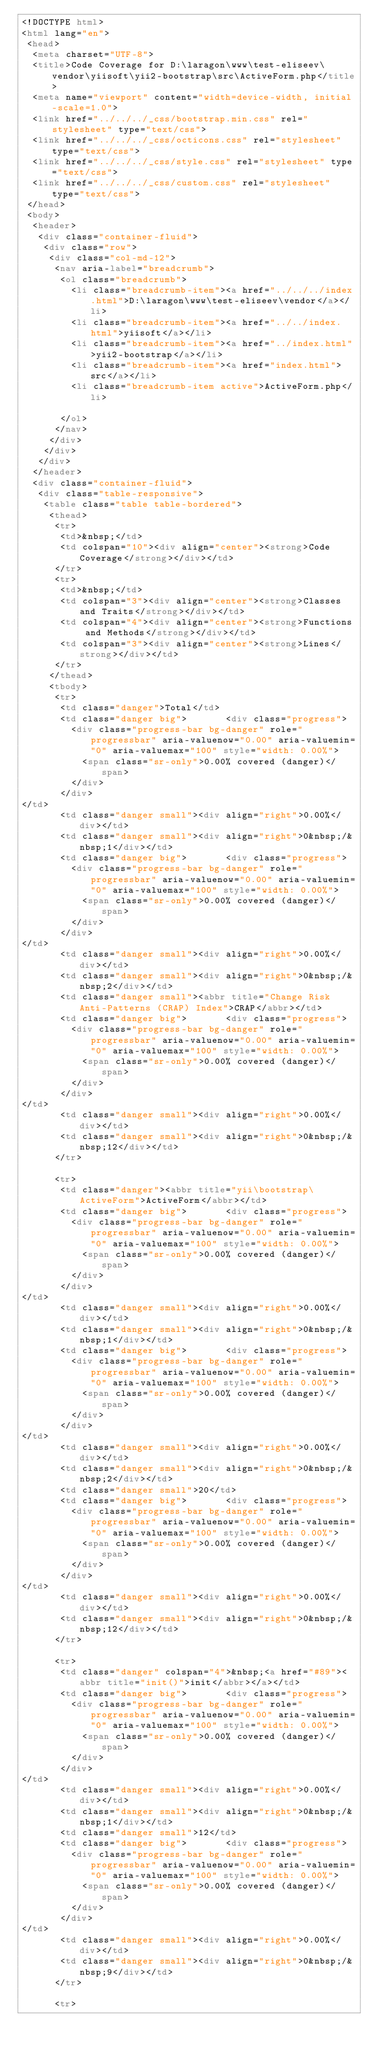Convert code to text. <code><loc_0><loc_0><loc_500><loc_500><_HTML_><!DOCTYPE html>
<html lang="en">
 <head>
  <meta charset="UTF-8">
  <title>Code Coverage for D:\laragon\www\test-eliseev\vendor\yiisoft\yii2-bootstrap\src\ActiveForm.php</title>
  <meta name="viewport" content="width=device-width, initial-scale=1.0">
  <link href="../../../_css/bootstrap.min.css" rel="stylesheet" type="text/css">
  <link href="../../../_css/octicons.css" rel="stylesheet" type="text/css">
  <link href="../../../_css/style.css" rel="stylesheet" type="text/css">
  <link href="../../../_css/custom.css" rel="stylesheet" type="text/css">
 </head>
 <body>
  <header>
   <div class="container-fluid">
    <div class="row">
     <div class="col-md-12">
      <nav aria-label="breadcrumb">
       <ol class="breadcrumb">
         <li class="breadcrumb-item"><a href="../../../index.html">D:\laragon\www\test-eliseev\vendor</a></li>
         <li class="breadcrumb-item"><a href="../../index.html">yiisoft</a></li>
         <li class="breadcrumb-item"><a href="../index.html">yii2-bootstrap</a></li>
         <li class="breadcrumb-item"><a href="index.html">src</a></li>
         <li class="breadcrumb-item active">ActiveForm.php</li>

       </ol>
      </nav>
     </div>
    </div>
   </div>
  </header>
  <div class="container-fluid">
   <div class="table-responsive">
    <table class="table table-bordered">
     <thead>
      <tr>
       <td>&nbsp;</td>
       <td colspan="10"><div align="center"><strong>Code Coverage</strong></div></td>
      </tr>
      <tr>
       <td>&nbsp;</td>
       <td colspan="3"><div align="center"><strong>Classes and Traits</strong></div></td>
       <td colspan="4"><div align="center"><strong>Functions and Methods</strong></div></td>
       <td colspan="3"><div align="center"><strong>Lines</strong></div></td>
      </tr>
     </thead>
     <tbody>
      <tr>
       <td class="danger">Total</td>
       <td class="danger big">       <div class="progress">
         <div class="progress-bar bg-danger" role="progressbar" aria-valuenow="0.00" aria-valuemin="0" aria-valuemax="100" style="width: 0.00%">
           <span class="sr-only">0.00% covered (danger)</span>
         </div>
       </div>
</td>
       <td class="danger small"><div align="right">0.00%</div></td>
       <td class="danger small"><div align="right">0&nbsp;/&nbsp;1</div></td>
       <td class="danger big">       <div class="progress">
         <div class="progress-bar bg-danger" role="progressbar" aria-valuenow="0.00" aria-valuemin="0" aria-valuemax="100" style="width: 0.00%">
           <span class="sr-only">0.00% covered (danger)</span>
         </div>
       </div>
</td>
       <td class="danger small"><div align="right">0.00%</div></td>
       <td class="danger small"><div align="right">0&nbsp;/&nbsp;2</div></td>
       <td class="danger small"><abbr title="Change Risk Anti-Patterns (CRAP) Index">CRAP</abbr></td>
       <td class="danger big">       <div class="progress">
         <div class="progress-bar bg-danger" role="progressbar" aria-valuenow="0.00" aria-valuemin="0" aria-valuemax="100" style="width: 0.00%">
           <span class="sr-only">0.00% covered (danger)</span>
         </div>
       </div>
</td>
       <td class="danger small"><div align="right">0.00%</div></td>
       <td class="danger small"><div align="right">0&nbsp;/&nbsp;12</div></td>
      </tr>

      <tr>
       <td class="danger"><abbr title="yii\bootstrap\ActiveForm">ActiveForm</abbr></td>
       <td class="danger big">       <div class="progress">
         <div class="progress-bar bg-danger" role="progressbar" aria-valuenow="0.00" aria-valuemin="0" aria-valuemax="100" style="width: 0.00%">
           <span class="sr-only">0.00% covered (danger)</span>
         </div>
       </div>
</td>
       <td class="danger small"><div align="right">0.00%</div></td>
       <td class="danger small"><div align="right">0&nbsp;/&nbsp;1</div></td>
       <td class="danger big">       <div class="progress">
         <div class="progress-bar bg-danger" role="progressbar" aria-valuenow="0.00" aria-valuemin="0" aria-valuemax="100" style="width: 0.00%">
           <span class="sr-only">0.00% covered (danger)</span>
         </div>
       </div>
</td>
       <td class="danger small"><div align="right">0.00%</div></td>
       <td class="danger small"><div align="right">0&nbsp;/&nbsp;2</div></td>
       <td class="danger small">20</td>
       <td class="danger big">       <div class="progress">
         <div class="progress-bar bg-danger" role="progressbar" aria-valuenow="0.00" aria-valuemin="0" aria-valuemax="100" style="width: 0.00%">
           <span class="sr-only">0.00% covered (danger)</span>
         </div>
       </div>
</td>
       <td class="danger small"><div align="right">0.00%</div></td>
       <td class="danger small"><div align="right">0&nbsp;/&nbsp;12</div></td>
      </tr>

      <tr>
       <td class="danger" colspan="4">&nbsp;<a href="#89"><abbr title="init()">init</abbr></a></td>
       <td class="danger big">       <div class="progress">
         <div class="progress-bar bg-danger" role="progressbar" aria-valuenow="0.00" aria-valuemin="0" aria-valuemax="100" style="width: 0.00%">
           <span class="sr-only">0.00% covered (danger)</span>
         </div>
       </div>
</td>
       <td class="danger small"><div align="right">0.00%</div></td>
       <td class="danger small"><div align="right">0&nbsp;/&nbsp;1</div></td>
       <td class="danger small">12</td>
       <td class="danger big">       <div class="progress">
         <div class="progress-bar bg-danger" role="progressbar" aria-valuenow="0.00" aria-valuemin="0" aria-valuemax="100" style="width: 0.00%">
           <span class="sr-only">0.00% covered (danger)</span>
         </div>
       </div>
</td>
       <td class="danger small"><div align="right">0.00%</div></td>
       <td class="danger small"><div align="right">0&nbsp;/&nbsp;9</div></td>
      </tr>

      <tr></code> 